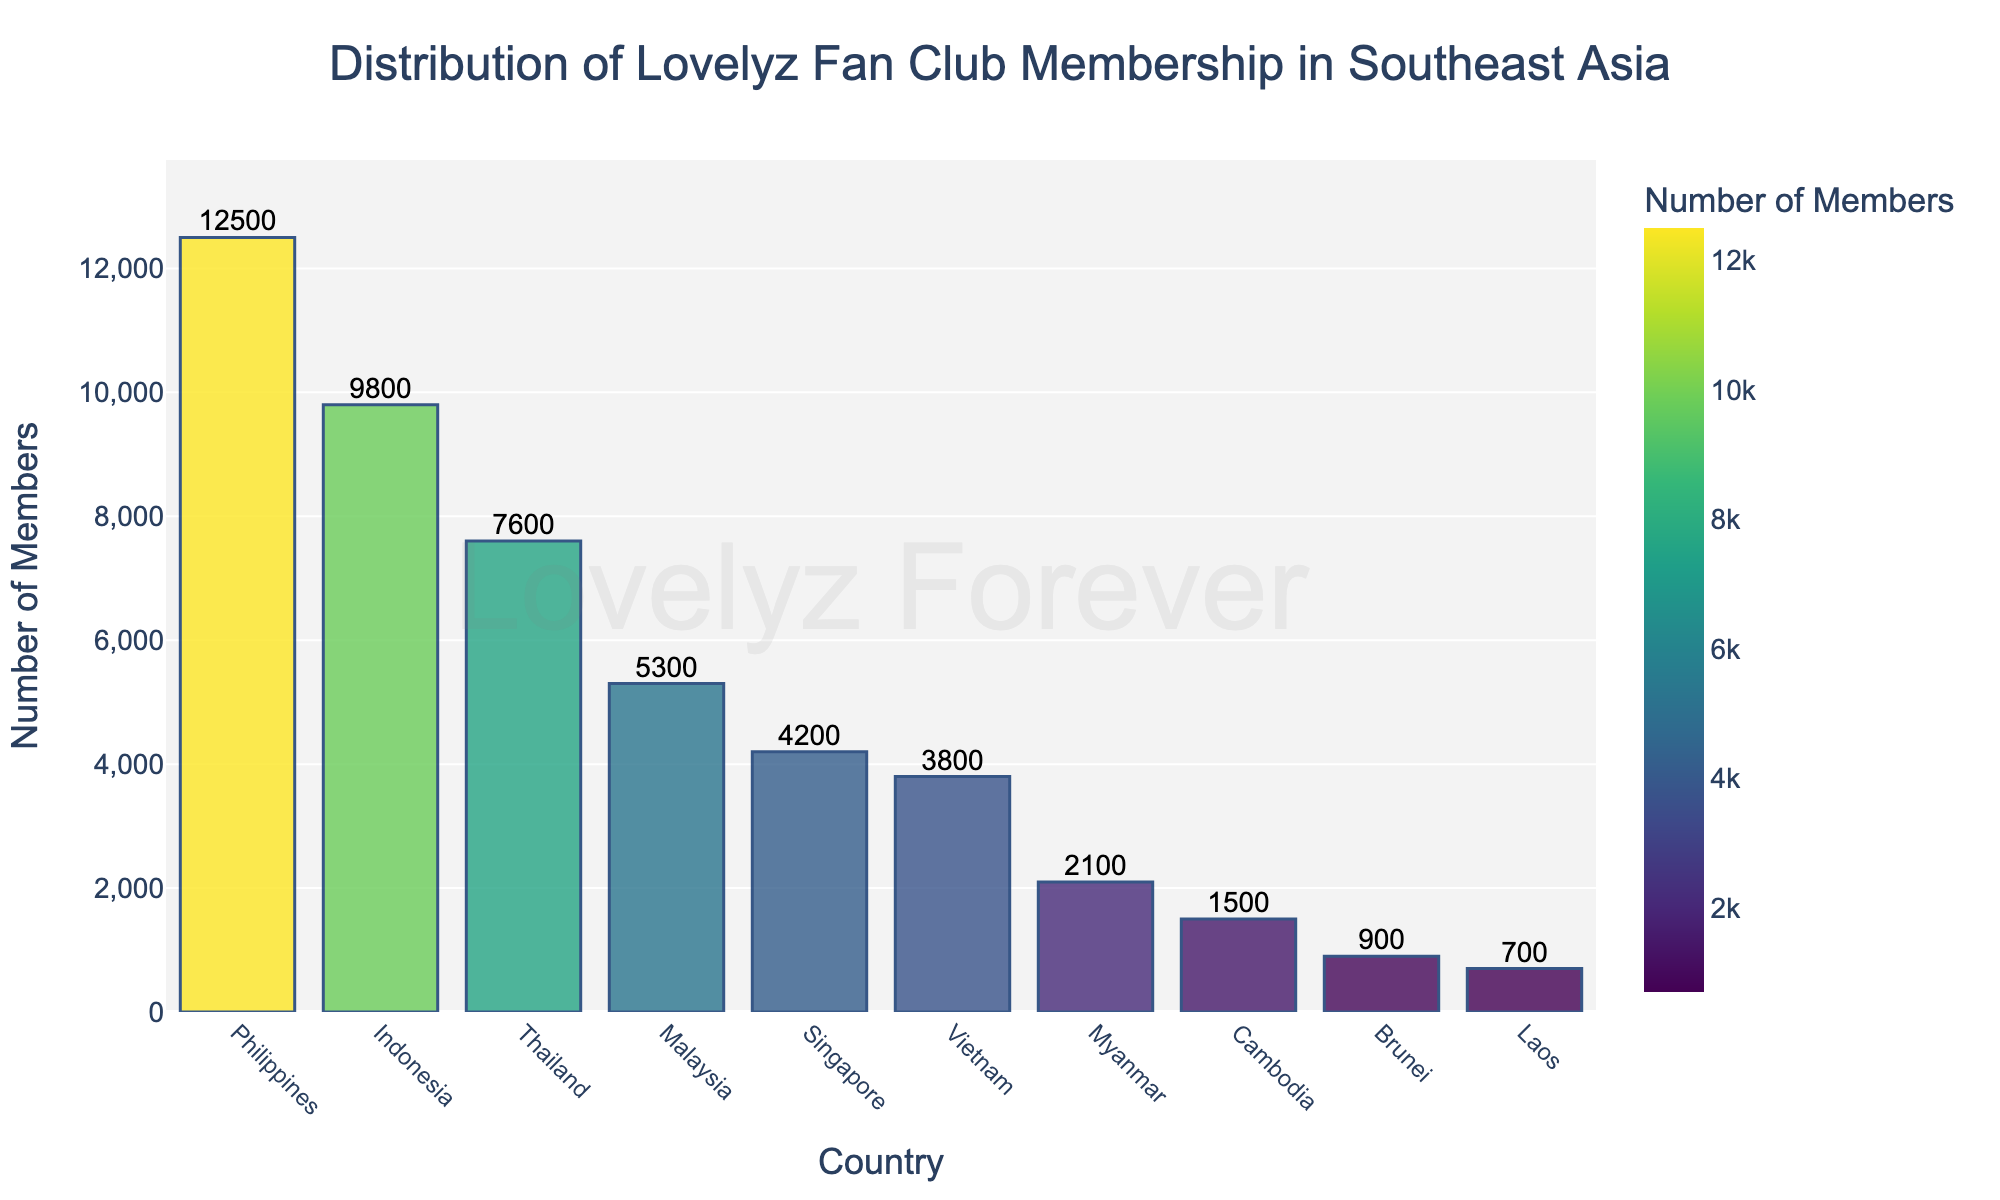What country has the most Lovelyz fan club members? The figure shows bar heights representing the number of Lovelyz fan club members per country. The highest bar is for the Philippines.
Answer: Philippines Which country has the second highest number of Lovelyz fan club members? The second tallest bar in the figure represents Indonesia.
Answer: Indonesia What is the combined total of Lovelyz fan club members in Thailand, Malaysia, and Singapore? Thailand has 7600 members, Malaysia has 5300, and Singapore has 4200. By adding these, 7600 + 5300 + 4200 = 17100 members.
Answer: 17100 How many more members does the Philippines have compared to Vietnam? The Philippines has 12500 members and Vietnam has 3800 members. The difference is 12500 - 3800 = 8700 members.
Answer: 8700 Which countries have fewer than 2000 Lovelyz fan club members? By looking at the bar heights, Cambodia, Brunei, and Laos have fewer than 2000 members, with 1500, 900, and 700 members respectively.
Answer: Cambodia, Brunei, Laos What is the average number of Lovelyz fan club members across all countries listed? Summing the members across all countries (12500 + 9800 + 7600 + 5300 + 4200 + 3800 + 2100 + 1500 + 900 + 700) gives 47600. There are 10 countries, so the average is 47600 / 10 = 4760 members.
Answer: 4760 Compare the number of Lovelyz fan club members in Indonesia to Malaysia. Which is greater and by how much? Indonesia has 9800 members, and Malaysia has 5300 members. Indonesia has more by 9800 - 5300 = 4500 members.
Answer: Indonesia by 4500 What is the range of Lovelyz fan club membership numbers across Southeast Asian countries? The range is found by subtracting the smallest number of members (Laos, 700) from the largest number of members (Philippines, 12500). Thus, 12500 - 700 = 11800.
Answer: 11800 Which country ranks third in the number of Lovelyz fan club members? The third tallest bar in the figure represents Thailand.
Answer: Thailand 